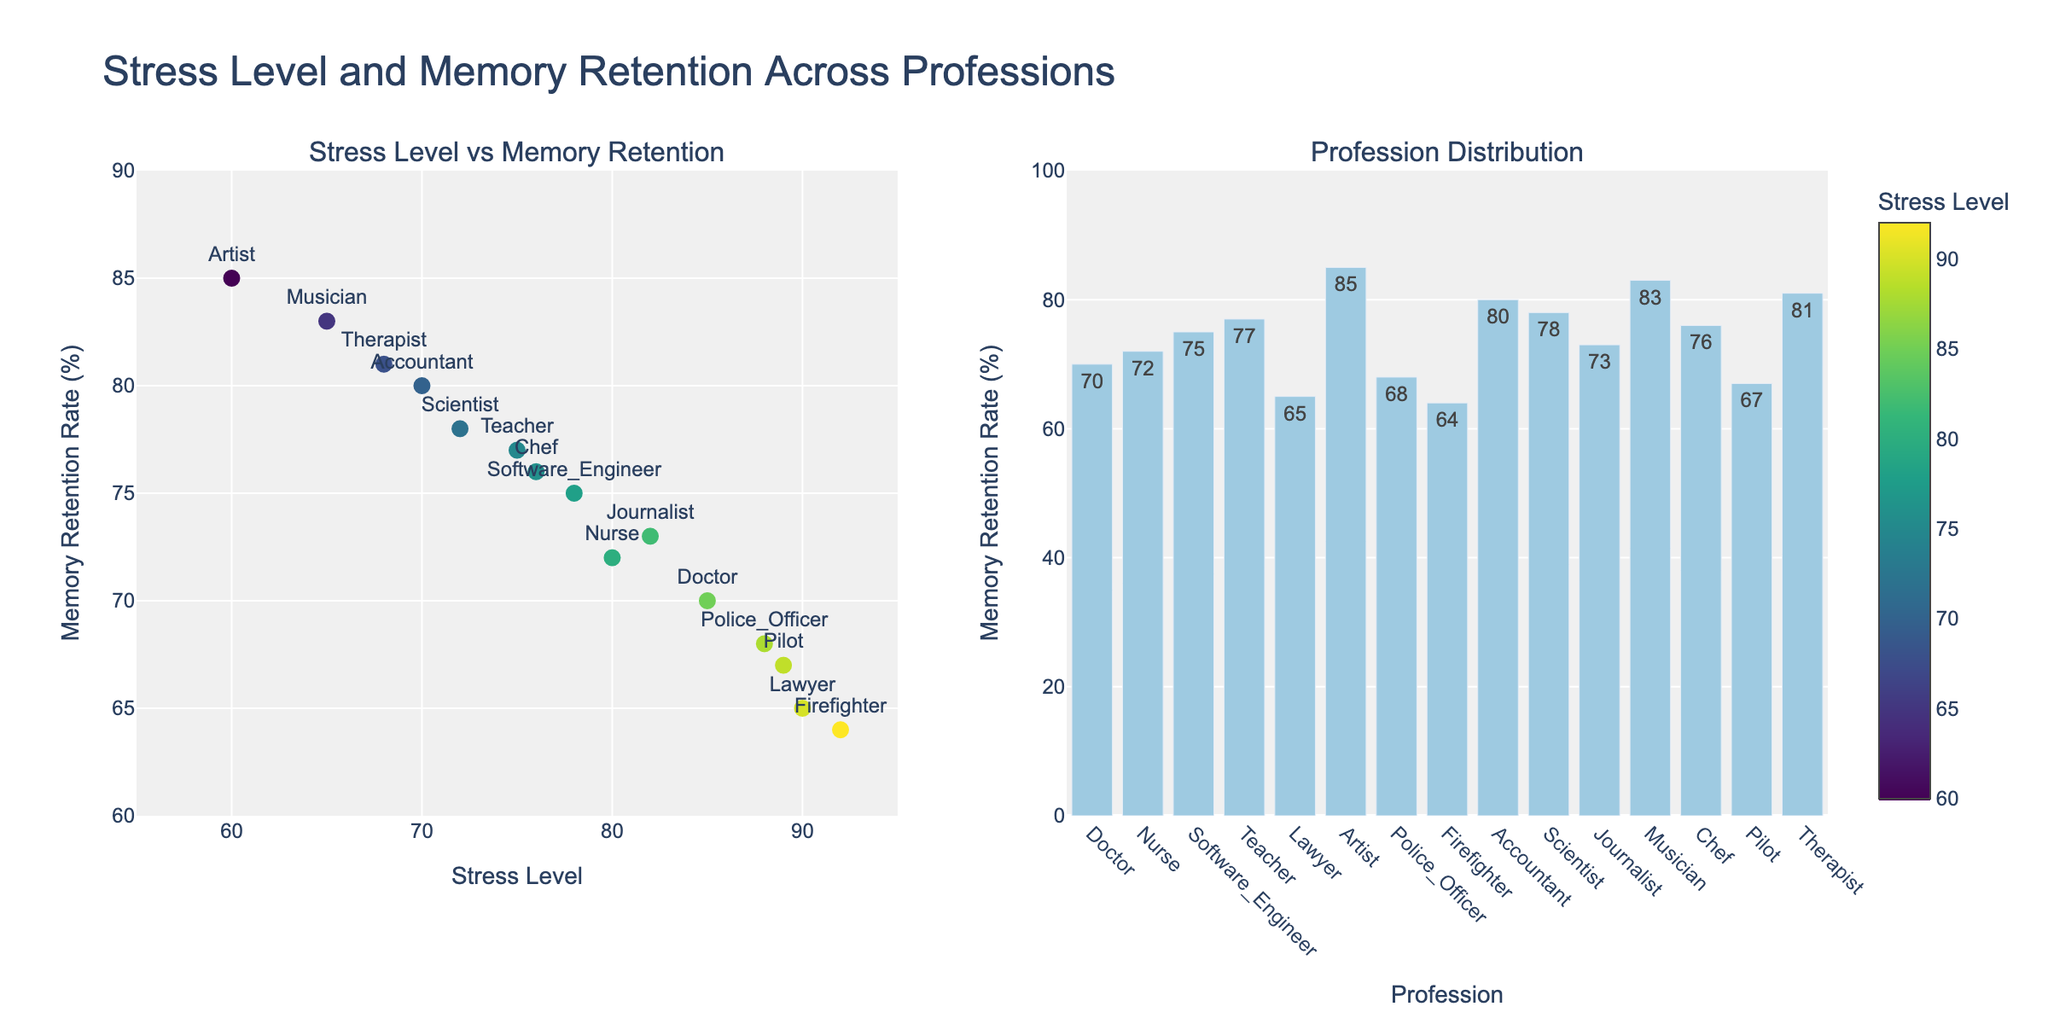What is the title of the figure? The figure's title is prominently displayed at the top, indicating the general context that the figure represents.
Answer: "Stress Level and Memory Retention Across Professions" What is the range of the y-axis in the scatter plot? The y-axis range is marked on the left side of the scatter plot, showing the limits of the Memory Retention Rate.
Answer: 60 to 90% Which profession has the highest stress level? Identify the point with the highest x-axis value (Stress Level) on the scatter plot. The profession label closest to this point indicates the answer.
Answer: Firefighter What is the average memory retention rate for the three least stressed professions? Identify the professions with the lowest stress levels (Artist, Musician, Therapist), sum their memory retention rates (85 + 83 + 81 = 249), and divide by the number of professions (249 / 3).
Answer: 83% How does the memory retention rate of a Scientist compare to that of a Teacher? Locate the points representing Scientist and Teacher on the scatter plot and compare their y-axis values.
Answer: The Scientist's memory retention rate (78%) is slightly higher than that of the Teacher (77%) What is the difference in memory retention rate between the Nurse and the Lawyer? Locate the Nurse and Lawyer data points on the scatter plot, note their y-axis values (Nurse: 72%, Lawyer: 65%), and subtract the smaller value from the larger one (72 - 65 = 7).
Answer: 7% Which profession has the lowest memory retention rate? Identify the point with the lowest y-axis value for Memory Retention Rate in the scatter plot or bar plot.
Answer: Firefighter Do higher stress levels generally correlate with lower memory retention rates? Assess the overall trend by observing the scatter plot to see if points with higher x-values (Stress Level) tend to have lower y-values (Memory Retention Rate).
Answer: Yes What is the range of memory retention rates in the bar plot? Examine the y-axis of the bar plot, noting the minimum and maximum values.
Answer: 60 to 90% How many professions have a memory retention rate of 80% or higher? Count the bars in the bar plot and points in the scatter plot with y-axis values of 80% or higher (Accountant, Scientist, Musician, Therapist, Artist).
Answer: 5 